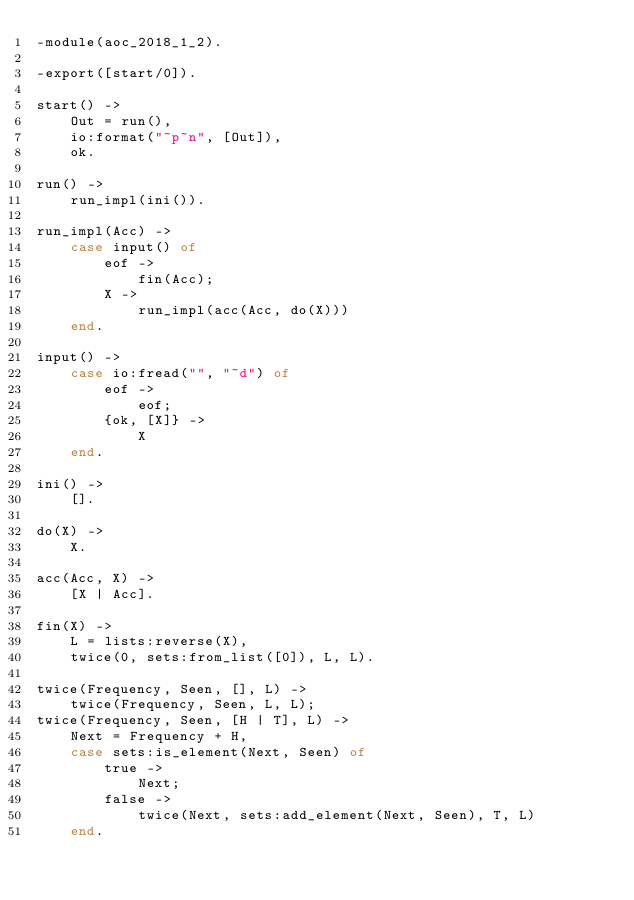<code> <loc_0><loc_0><loc_500><loc_500><_Erlang_>-module(aoc_2018_1_2).

-export([start/0]).

start() ->
    Out = run(),
    io:format("~p~n", [Out]),
    ok.

run() ->
    run_impl(ini()).

run_impl(Acc) ->
    case input() of
        eof ->
            fin(Acc);
        X ->
            run_impl(acc(Acc, do(X)))
    end.

input() ->
    case io:fread("", "~d") of
        eof ->
            eof;
        {ok, [X]} ->
            X
    end.

ini() ->
    [].

do(X) ->
    X.

acc(Acc, X) ->
    [X | Acc].

fin(X) ->
    L = lists:reverse(X),
    twice(0, sets:from_list([0]), L, L).

twice(Frequency, Seen, [], L) ->
    twice(Frequency, Seen, L, L);
twice(Frequency, Seen, [H | T], L) ->
    Next = Frequency + H,
    case sets:is_element(Next, Seen) of
        true ->
            Next;
        false ->
            twice(Next, sets:add_element(Next, Seen), T, L)
    end.
</code> 